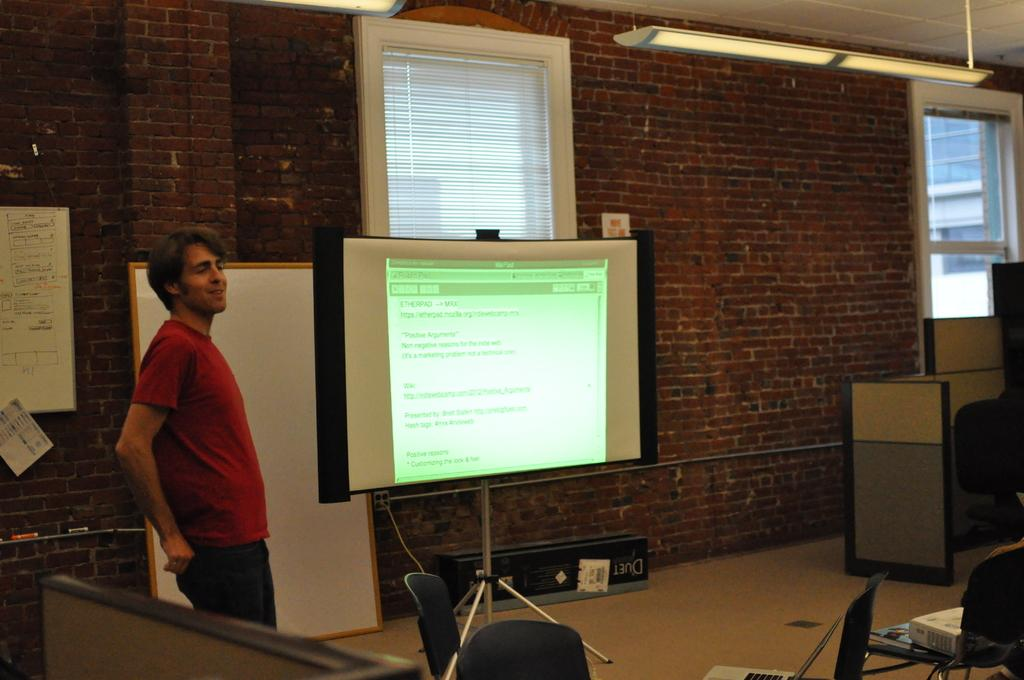Who is present in the image? There is a man in the image. Where is the man located in the image? The man is on the left side of the image. What is the man wearing? The man is wearing a red t-shirt. What can be seen to the right of the man? There is a projector display to the right of the man. What type of structure is visible in the image? There is a brick wall in the image. How many windows are present in the image? There are two windows in the image. What sense does the man appear to be experiencing in the image? The image does not provide any information about the man's senses or experiences. How comfortable does the man look in the image? The image does not provide any information about the man's comfort level. 